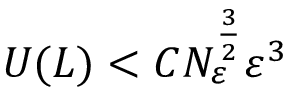Convert formula to latex. <formula><loc_0><loc_0><loc_500><loc_500>U ( L ) < C N _ { \varepsilon } ^ { \frac { 3 } { 2 } } \varepsilon ^ { 3 }</formula> 